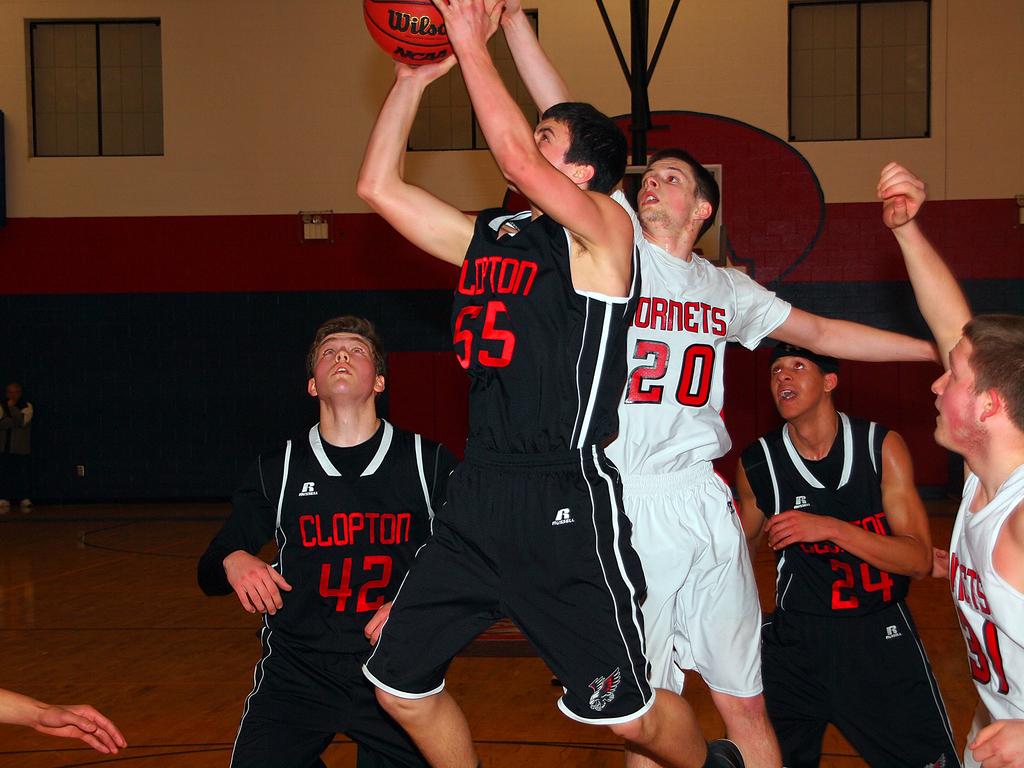What is the name of the school on the front of the black jerseys?
Your response must be concise. Clopton. What number is on the white jersey?
Your response must be concise. 20. 